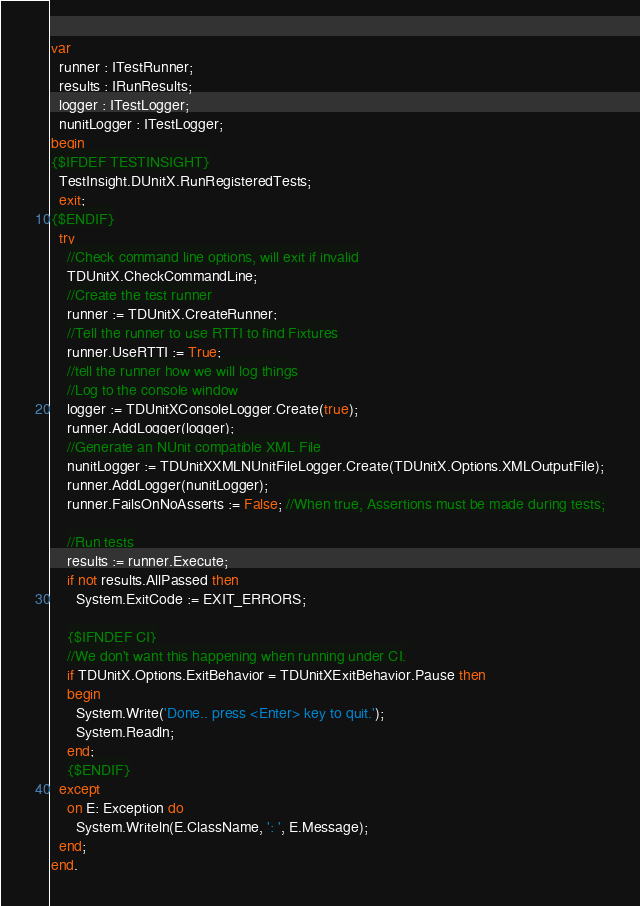<code> <loc_0><loc_0><loc_500><loc_500><_Pascal_>var
  runner : ITestRunner;
  results : IRunResults;
  logger : ITestLogger;
  nunitLogger : ITestLogger;
begin
{$IFDEF TESTINSIGHT}
  TestInsight.DUnitX.RunRegisteredTests;
  exit;
{$ENDIF}
  try
    //Check command line options, will exit if invalid
    TDUnitX.CheckCommandLine;
    //Create the test runner
    runner := TDUnitX.CreateRunner;
    //Tell the runner to use RTTI to find Fixtures
    runner.UseRTTI := True;
    //tell the runner how we will log things
    //Log to the console window
    logger := TDUnitXConsoleLogger.Create(true);
    runner.AddLogger(logger);
    //Generate an NUnit compatible XML File
    nunitLogger := TDUnitXXMLNUnitFileLogger.Create(TDUnitX.Options.XMLOutputFile);
    runner.AddLogger(nunitLogger);
    runner.FailsOnNoAsserts := False; //When true, Assertions must be made during tests;

    //Run tests
    results := runner.Execute;
    if not results.AllPassed then
      System.ExitCode := EXIT_ERRORS;

    {$IFNDEF CI}
    //We don't want this happening when running under CI.
    if TDUnitX.Options.ExitBehavior = TDUnitXExitBehavior.Pause then
    begin
      System.Write('Done.. press <Enter> key to quit.');
      System.Readln;
    end;
    {$ENDIF}
  except
    on E: Exception do
      System.Writeln(E.ClassName, ': ', E.Message);
  end;
end.
</code> 